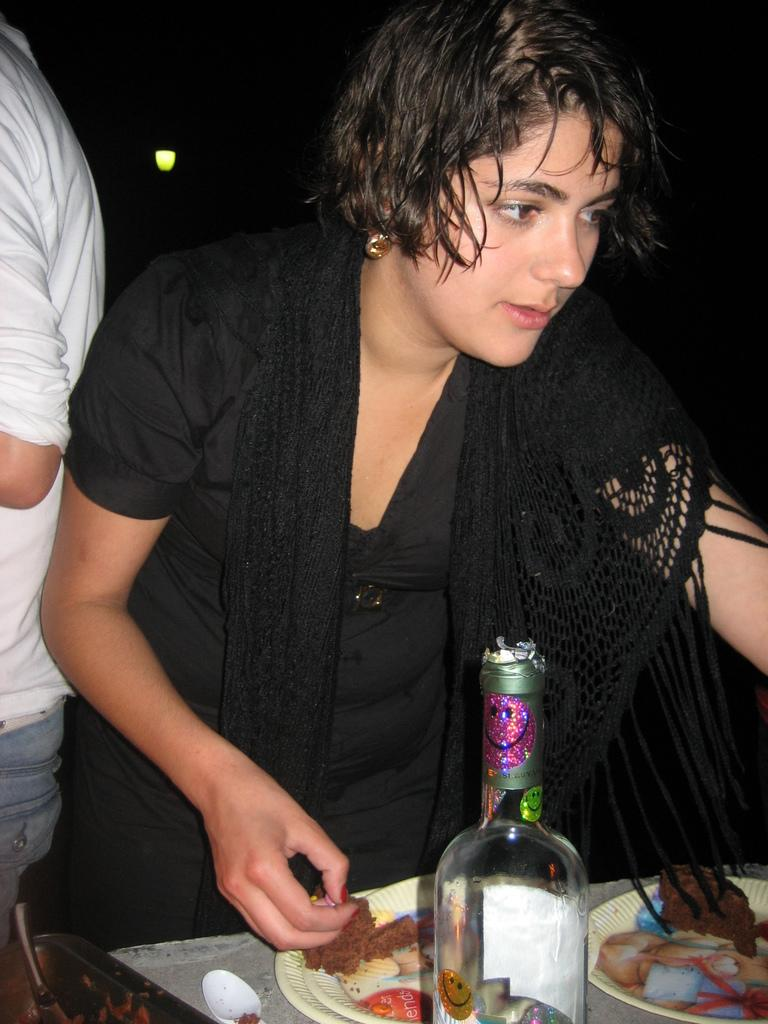Who is present in the image? There is a woman in the image. What is the woman doing in the image? The woman is standing in the image. What can be seen on the table in the image? There are two plates with food and a bottle in front of the woman. Can you describe the other person in the image? There is another person in the background of the image. What type of impulse can be seen affecting the plates in the image? There is no impulse affecting the plates in the image; they are stationary on the table. How many pizzas are visible on the plates in the image? The provided facts do not mention pizzas; there are only two plates with food, but the specific type of food is not specified. 